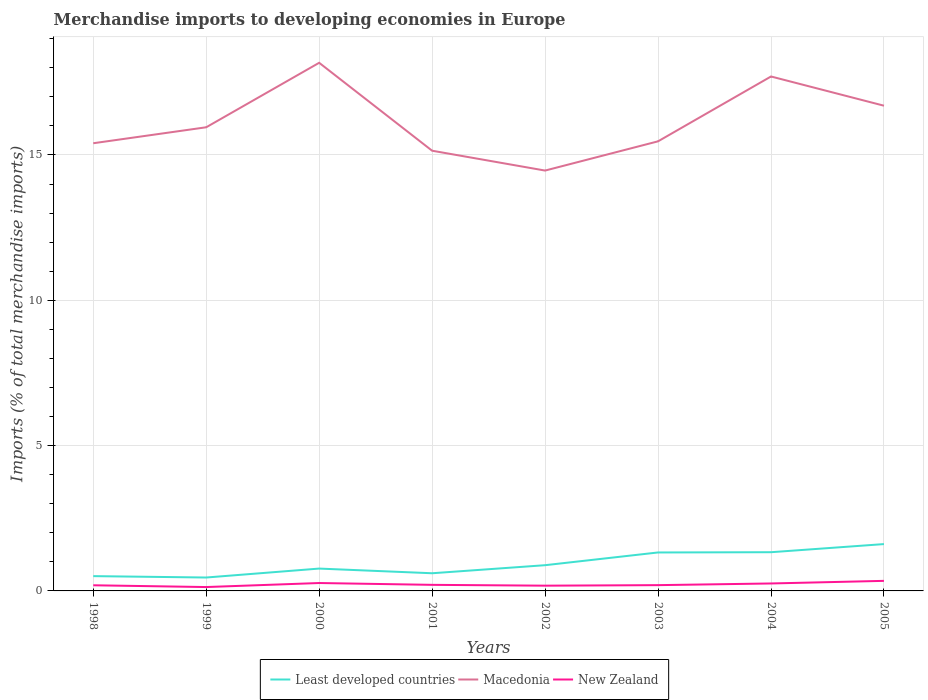How many different coloured lines are there?
Your response must be concise. 3. Is the number of lines equal to the number of legend labels?
Ensure brevity in your answer.  Yes. Across all years, what is the maximum percentage total merchandise imports in Macedonia?
Your response must be concise. 14.46. What is the total percentage total merchandise imports in Least developed countries in the graph?
Give a very brief answer. -0.72. What is the difference between the highest and the second highest percentage total merchandise imports in Least developed countries?
Offer a very short reply. 1.15. Is the percentage total merchandise imports in Least developed countries strictly greater than the percentage total merchandise imports in Macedonia over the years?
Your answer should be compact. Yes. How many lines are there?
Offer a terse response. 3. How many years are there in the graph?
Your answer should be compact. 8. Are the values on the major ticks of Y-axis written in scientific E-notation?
Your answer should be compact. No. Does the graph contain any zero values?
Your answer should be very brief. No. Does the graph contain grids?
Your answer should be compact. Yes. Where does the legend appear in the graph?
Your answer should be compact. Bottom center. How many legend labels are there?
Offer a very short reply. 3. How are the legend labels stacked?
Your response must be concise. Horizontal. What is the title of the graph?
Provide a short and direct response. Merchandise imports to developing economies in Europe. Does "San Marino" appear as one of the legend labels in the graph?
Your answer should be compact. No. What is the label or title of the Y-axis?
Your answer should be compact. Imports (% of total merchandise imports). What is the Imports (% of total merchandise imports) of Least developed countries in 1998?
Offer a very short reply. 0.51. What is the Imports (% of total merchandise imports) in Macedonia in 1998?
Ensure brevity in your answer.  15.4. What is the Imports (% of total merchandise imports) of New Zealand in 1998?
Offer a very short reply. 0.19. What is the Imports (% of total merchandise imports) of Least developed countries in 1999?
Offer a very short reply. 0.46. What is the Imports (% of total merchandise imports) of Macedonia in 1999?
Make the answer very short. 15.95. What is the Imports (% of total merchandise imports) in New Zealand in 1999?
Offer a very short reply. 0.13. What is the Imports (% of total merchandise imports) of Least developed countries in 2000?
Offer a terse response. 0.77. What is the Imports (% of total merchandise imports) in Macedonia in 2000?
Keep it short and to the point. 18.17. What is the Imports (% of total merchandise imports) of New Zealand in 2000?
Offer a terse response. 0.27. What is the Imports (% of total merchandise imports) of Least developed countries in 2001?
Give a very brief answer. 0.61. What is the Imports (% of total merchandise imports) of Macedonia in 2001?
Offer a very short reply. 15.15. What is the Imports (% of total merchandise imports) in New Zealand in 2001?
Make the answer very short. 0.21. What is the Imports (% of total merchandise imports) in Least developed countries in 2002?
Ensure brevity in your answer.  0.89. What is the Imports (% of total merchandise imports) of Macedonia in 2002?
Your answer should be compact. 14.46. What is the Imports (% of total merchandise imports) of New Zealand in 2002?
Provide a short and direct response. 0.18. What is the Imports (% of total merchandise imports) of Least developed countries in 2003?
Your response must be concise. 1.32. What is the Imports (% of total merchandise imports) in Macedonia in 2003?
Keep it short and to the point. 15.47. What is the Imports (% of total merchandise imports) in New Zealand in 2003?
Ensure brevity in your answer.  0.2. What is the Imports (% of total merchandise imports) of Least developed countries in 2004?
Make the answer very short. 1.33. What is the Imports (% of total merchandise imports) of Macedonia in 2004?
Offer a terse response. 17.7. What is the Imports (% of total merchandise imports) in New Zealand in 2004?
Give a very brief answer. 0.26. What is the Imports (% of total merchandise imports) of Least developed countries in 2005?
Ensure brevity in your answer.  1.61. What is the Imports (% of total merchandise imports) of Macedonia in 2005?
Make the answer very short. 16.7. What is the Imports (% of total merchandise imports) of New Zealand in 2005?
Offer a very short reply. 0.35. Across all years, what is the maximum Imports (% of total merchandise imports) in Least developed countries?
Make the answer very short. 1.61. Across all years, what is the maximum Imports (% of total merchandise imports) of Macedonia?
Your answer should be compact. 18.17. Across all years, what is the maximum Imports (% of total merchandise imports) in New Zealand?
Your answer should be very brief. 0.35. Across all years, what is the minimum Imports (% of total merchandise imports) of Least developed countries?
Make the answer very short. 0.46. Across all years, what is the minimum Imports (% of total merchandise imports) in Macedonia?
Make the answer very short. 14.46. Across all years, what is the minimum Imports (% of total merchandise imports) in New Zealand?
Your answer should be compact. 0.13. What is the total Imports (% of total merchandise imports) in Least developed countries in the graph?
Your response must be concise. 7.5. What is the total Imports (% of total merchandise imports) of Macedonia in the graph?
Keep it short and to the point. 129. What is the total Imports (% of total merchandise imports) of New Zealand in the graph?
Offer a very short reply. 1.79. What is the difference between the Imports (% of total merchandise imports) in Least developed countries in 1998 and that in 1999?
Offer a terse response. 0.05. What is the difference between the Imports (% of total merchandise imports) in Macedonia in 1998 and that in 1999?
Keep it short and to the point. -0.55. What is the difference between the Imports (% of total merchandise imports) of New Zealand in 1998 and that in 1999?
Your response must be concise. 0.06. What is the difference between the Imports (% of total merchandise imports) of Least developed countries in 1998 and that in 2000?
Your answer should be compact. -0.26. What is the difference between the Imports (% of total merchandise imports) of Macedonia in 1998 and that in 2000?
Your answer should be very brief. -2.77. What is the difference between the Imports (% of total merchandise imports) of New Zealand in 1998 and that in 2000?
Provide a short and direct response. -0.08. What is the difference between the Imports (% of total merchandise imports) of Least developed countries in 1998 and that in 2001?
Your answer should be very brief. -0.1. What is the difference between the Imports (% of total merchandise imports) in Macedonia in 1998 and that in 2001?
Your answer should be very brief. 0.26. What is the difference between the Imports (% of total merchandise imports) of New Zealand in 1998 and that in 2001?
Provide a succinct answer. -0.01. What is the difference between the Imports (% of total merchandise imports) in Least developed countries in 1998 and that in 2002?
Keep it short and to the point. -0.38. What is the difference between the Imports (% of total merchandise imports) of Macedonia in 1998 and that in 2002?
Offer a terse response. 0.94. What is the difference between the Imports (% of total merchandise imports) of New Zealand in 1998 and that in 2002?
Your answer should be very brief. 0.01. What is the difference between the Imports (% of total merchandise imports) in Least developed countries in 1998 and that in 2003?
Offer a terse response. -0.81. What is the difference between the Imports (% of total merchandise imports) of Macedonia in 1998 and that in 2003?
Your answer should be very brief. -0.07. What is the difference between the Imports (% of total merchandise imports) in New Zealand in 1998 and that in 2003?
Your answer should be compact. -0. What is the difference between the Imports (% of total merchandise imports) of Least developed countries in 1998 and that in 2004?
Your answer should be compact. -0.82. What is the difference between the Imports (% of total merchandise imports) of Macedonia in 1998 and that in 2004?
Give a very brief answer. -2.3. What is the difference between the Imports (% of total merchandise imports) in New Zealand in 1998 and that in 2004?
Offer a very short reply. -0.06. What is the difference between the Imports (% of total merchandise imports) in Least developed countries in 1998 and that in 2005?
Your answer should be compact. -1.1. What is the difference between the Imports (% of total merchandise imports) of Macedonia in 1998 and that in 2005?
Your answer should be very brief. -1.29. What is the difference between the Imports (% of total merchandise imports) in New Zealand in 1998 and that in 2005?
Provide a short and direct response. -0.15. What is the difference between the Imports (% of total merchandise imports) of Least developed countries in 1999 and that in 2000?
Provide a succinct answer. -0.31. What is the difference between the Imports (% of total merchandise imports) of Macedonia in 1999 and that in 2000?
Provide a short and direct response. -2.22. What is the difference between the Imports (% of total merchandise imports) in New Zealand in 1999 and that in 2000?
Keep it short and to the point. -0.14. What is the difference between the Imports (% of total merchandise imports) in Least developed countries in 1999 and that in 2001?
Make the answer very short. -0.15. What is the difference between the Imports (% of total merchandise imports) in Macedonia in 1999 and that in 2001?
Your answer should be compact. 0.81. What is the difference between the Imports (% of total merchandise imports) in New Zealand in 1999 and that in 2001?
Offer a terse response. -0.08. What is the difference between the Imports (% of total merchandise imports) in Least developed countries in 1999 and that in 2002?
Your response must be concise. -0.42. What is the difference between the Imports (% of total merchandise imports) in Macedonia in 1999 and that in 2002?
Provide a short and direct response. 1.49. What is the difference between the Imports (% of total merchandise imports) of New Zealand in 1999 and that in 2002?
Make the answer very short. -0.05. What is the difference between the Imports (% of total merchandise imports) in Least developed countries in 1999 and that in 2003?
Give a very brief answer. -0.86. What is the difference between the Imports (% of total merchandise imports) of Macedonia in 1999 and that in 2003?
Your answer should be compact. 0.48. What is the difference between the Imports (% of total merchandise imports) in New Zealand in 1999 and that in 2003?
Offer a very short reply. -0.07. What is the difference between the Imports (% of total merchandise imports) in Least developed countries in 1999 and that in 2004?
Provide a short and direct response. -0.87. What is the difference between the Imports (% of total merchandise imports) in Macedonia in 1999 and that in 2004?
Provide a succinct answer. -1.75. What is the difference between the Imports (% of total merchandise imports) in New Zealand in 1999 and that in 2004?
Ensure brevity in your answer.  -0.12. What is the difference between the Imports (% of total merchandise imports) in Least developed countries in 1999 and that in 2005?
Offer a terse response. -1.15. What is the difference between the Imports (% of total merchandise imports) of Macedonia in 1999 and that in 2005?
Keep it short and to the point. -0.74. What is the difference between the Imports (% of total merchandise imports) in New Zealand in 1999 and that in 2005?
Offer a terse response. -0.21. What is the difference between the Imports (% of total merchandise imports) of Least developed countries in 2000 and that in 2001?
Make the answer very short. 0.16. What is the difference between the Imports (% of total merchandise imports) in Macedonia in 2000 and that in 2001?
Keep it short and to the point. 3.03. What is the difference between the Imports (% of total merchandise imports) of New Zealand in 2000 and that in 2001?
Offer a very short reply. 0.06. What is the difference between the Imports (% of total merchandise imports) in Least developed countries in 2000 and that in 2002?
Give a very brief answer. -0.12. What is the difference between the Imports (% of total merchandise imports) of Macedonia in 2000 and that in 2002?
Keep it short and to the point. 3.71. What is the difference between the Imports (% of total merchandise imports) of New Zealand in 2000 and that in 2002?
Your response must be concise. 0.09. What is the difference between the Imports (% of total merchandise imports) of Least developed countries in 2000 and that in 2003?
Provide a short and direct response. -0.55. What is the difference between the Imports (% of total merchandise imports) in Macedonia in 2000 and that in 2003?
Ensure brevity in your answer.  2.7. What is the difference between the Imports (% of total merchandise imports) in New Zealand in 2000 and that in 2003?
Offer a very short reply. 0.07. What is the difference between the Imports (% of total merchandise imports) of Least developed countries in 2000 and that in 2004?
Provide a short and direct response. -0.56. What is the difference between the Imports (% of total merchandise imports) in Macedonia in 2000 and that in 2004?
Your answer should be very brief. 0.47. What is the difference between the Imports (% of total merchandise imports) of New Zealand in 2000 and that in 2004?
Ensure brevity in your answer.  0.02. What is the difference between the Imports (% of total merchandise imports) of Least developed countries in 2000 and that in 2005?
Provide a succinct answer. -0.84. What is the difference between the Imports (% of total merchandise imports) of Macedonia in 2000 and that in 2005?
Your answer should be very brief. 1.48. What is the difference between the Imports (% of total merchandise imports) of New Zealand in 2000 and that in 2005?
Offer a very short reply. -0.07. What is the difference between the Imports (% of total merchandise imports) in Least developed countries in 2001 and that in 2002?
Make the answer very short. -0.28. What is the difference between the Imports (% of total merchandise imports) of Macedonia in 2001 and that in 2002?
Make the answer very short. 0.68. What is the difference between the Imports (% of total merchandise imports) in New Zealand in 2001 and that in 2002?
Give a very brief answer. 0.03. What is the difference between the Imports (% of total merchandise imports) in Least developed countries in 2001 and that in 2003?
Your answer should be very brief. -0.72. What is the difference between the Imports (% of total merchandise imports) of Macedonia in 2001 and that in 2003?
Offer a very short reply. -0.32. What is the difference between the Imports (% of total merchandise imports) of New Zealand in 2001 and that in 2003?
Ensure brevity in your answer.  0.01. What is the difference between the Imports (% of total merchandise imports) in Least developed countries in 2001 and that in 2004?
Keep it short and to the point. -0.72. What is the difference between the Imports (% of total merchandise imports) in Macedonia in 2001 and that in 2004?
Offer a very short reply. -2.55. What is the difference between the Imports (% of total merchandise imports) in New Zealand in 2001 and that in 2004?
Offer a very short reply. -0.05. What is the difference between the Imports (% of total merchandise imports) of Least developed countries in 2001 and that in 2005?
Make the answer very short. -1. What is the difference between the Imports (% of total merchandise imports) in Macedonia in 2001 and that in 2005?
Ensure brevity in your answer.  -1.55. What is the difference between the Imports (% of total merchandise imports) in New Zealand in 2001 and that in 2005?
Provide a succinct answer. -0.14. What is the difference between the Imports (% of total merchandise imports) in Least developed countries in 2002 and that in 2003?
Give a very brief answer. -0.44. What is the difference between the Imports (% of total merchandise imports) in Macedonia in 2002 and that in 2003?
Offer a very short reply. -1.01. What is the difference between the Imports (% of total merchandise imports) of New Zealand in 2002 and that in 2003?
Give a very brief answer. -0.02. What is the difference between the Imports (% of total merchandise imports) in Least developed countries in 2002 and that in 2004?
Provide a succinct answer. -0.45. What is the difference between the Imports (% of total merchandise imports) of Macedonia in 2002 and that in 2004?
Offer a terse response. -3.24. What is the difference between the Imports (% of total merchandise imports) of New Zealand in 2002 and that in 2004?
Your response must be concise. -0.08. What is the difference between the Imports (% of total merchandise imports) of Least developed countries in 2002 and that in 2005?
Give a very brief answer. -0.73. What is the difference between the Imports (% of total merchandise imports) of Macedonia in 2002 and that in 2005?
Keep it short and to the point. -2.23. What is the difference between the Imports (% of total merchandise imports) in New Zealand in 2002 and that in 2005?
Provide a succinct answer. -0.17. What is the difference between the Imports (% of total merchandise imports) in Least developed countries in 2003 and that in 2004?
Ensure brevity in your answer.  -0.01. What is the difference between the Imports (% of total merchandise imports) of Macedonia in 2003 and that in 2004?
Provide a succinct answer. -2.23. What is the difference between the Imports (% of total merchandise imports) of New Zealand in 2003 and that in 2004?
Make the answer very short. -0.06. What is the difference between the Imports (% of total merchandise imports) of Least developed countries in 2003 and that in 2005?
Make the answer very short. -0.29. What is the difference between the Imports (% of total merchandise imports) in Macedonia in 2003 and that in 2005?
Ensure brevity in your answer.  -1.23. What is the difference between the Imports (% of total merchandise imports) of New Zealand in 2003 and that in 2005?
Give a very brief answer. -0.15. What is the difference between the Imports (% of total merchandise imports) of Least developed countries in 2004 and that in 2005?
Give a very brief answer. -0.28. What is the difference between the Imports (% of total merchandise imports) of Macedonia in 2004 and that in 2005?
Give a very brief answer. 1. What is the difference between the Imports (% of total merchandise imports) of New Zealand in 2004 and that in 2005?
Keep it short and to the point. -0.09. What is the difference between the Imports (% of total merchandise imports) of Least developed countries in 1998 and the Imports (% of total merchandise imports) of Macedonia in 1999?
Keep it short and to the point. -15.44. What is the difference between the Imports (% of total merchandise imports) in Least developed countries in 1998 and the Imports (% of total merchandise imports) in New Zealand in 1999?
Provide a succinct answer. 0.38. What is the difference between the Imports (% of total merchandise imports) of Macedonia in 1998 and the Imports (% of total merchandise imports) of New Zealand in 1999?
Give a very brief answer. 15.27. What is the difference between the Imports (% of total merchandise imports) of Least developed countries in 1998 and the Imports (% of total merchandise imports) of Macedonia in 2000?
Keep it short and to the point. -17.66. What is the difference between the Imports (% of total merchandise imports) of Least developed countries in 1998 and the Imports (% of total merchandise imports) of New Zealand in 2000?
Ensure brevity in your answer.  0.24. What is the difference between the Imports (% of total merchandise imports) of Macedonia in 1998 and the Imports (% of total merchandise imports) of New Zealand in 2000?
Ensure brevity in your answer.  15.13. What is the difference between the Imports (% of total merchandise imports) of Least developed countries in 1998 and the Imports (% of total merchandise imports) of Macedonia in 2001?
Provide a short and direct response. -14.64. What is the difference between the Imports (% of total merchandise imports) in Least developed countries in 1998 and the Imports (% of total merchandise imports) in New Zealand in 2001?
Your answer should be very brief. 0.3. What is the difference between the Imports (% of total merchandise imports) in Macedonia in 1998 and the Imports (% of total merchandise imports) in New Zealand in 2001?
Your answer should be very brief. 15.19. What is the difference between the Imports (% of total merchandise imports) in Least developed countries in 1998 and the Imports (% of total merchandise imports) in Macedonia in 2002?
Give a very brief answer. -13.95. What is the difference between the Imports (% of total merchandise imports) of Least developed countries in 1998 and the Imports (% of total merchandise imports) of New Zealand in 2002?
Offer a terse response. 0.33. What is the difference between the Imports (% of total merchandise imports) of Macedonia in 1998 and the Imports (% of total merchandise imports) of New Zealand in 2002?
Make the answer very short. 15.22. What is the difference between the Imports (% of total merchandise imports) of Least developed countries in 1998 and the Imports (% of total merchandise imports) of Macedonia in 2003?
Give a very brief answer. -14.96. What is the difference between the Imports (% of total merchandise imports) in Least developed countries in 1998 and the Imports (% of total merchandise imports) in New Zealand in 2003?
Offer a very short reply. 0.31. What is the difference between the Imports (% of total merchandise imports) of Macedonia in 1998 and the Imports (% of total merchandise imports) of New Zealand in 2003?
Offer a terse response. 15.21. What is the difference between the Imports (% of total merchandise imports) of Least developed countries in 1998 and the Imports (% of total merchandise imports) of Macedonia in 2004?
Make the answer very short. -17.19. What is the difference between the Imports (% of total merchandise imports) in Least developed countries in 1998 and the Imports (% of total merchandise imports) in New Zealand in 2004?
Keep it short and to the point. 0.25. What is the difference between the Imports (% of total merchandise imports) of Macedonia in 1998 and the Imports (% of total merchandise imports) of New Zealand in 2004?
Provide a succinct answer. 15.15. What is the difference between the Imports (% of total merchandise imports) of Least developed countries in 1998 and the Imports (% of total merchandise imports) of Macedonia in 2005?
Keep it short and to the point. -16.19. What is the difference between the Imports (% of total merchandise imports) in Least developed countries in 1998 and the Imports (% of total merchandise imports) in New Zealand in 2005?
Provide a short and direct response. 0.16. What is the difference between the Imports (% of total merchandise imports) of Macedonia in 1998 and the Imports (% of total merchandise imports) of New Zealand in 2005?
Ensure brevity in your answer.  15.06. What is the difference between the Imports (% of total merchandise imports) in Least developed countries in 1999 and the Imports (% of total merchandise imports) in Macedonia in 2000?
Your response must be concise. -17.71. What is the difference between the Imports (% of total merchandise imports) of Least developed countries in 1999 and the Imports (% of total merchandise imports) of New Zealand in 2000?
Ensure brevity in your answer.  0.19. What is the difference between the Imports (% of total merchandise imports) in Macedonia in 1999 and the Imports (% of total merchandise imports) in New Zealand in 2000?
Provide a short and direct response. 15.68. What is the difference between the Imports (% of total merchandise imports) of Least developed countries in 1999 and the Imports (% of total merchandise imports) of Macedonia in 2001?
Offer a very short reply. -14.69. What is the difference between the Imports (% of total merchandise imports) of Least developed countries in 1999 and the Imports (% of total merchandise imports) of New Zealand in 2001?
Provide a short and direct response. 0.25. What is the difference between the Imports (% of total merchandise imports) in Macedonia in 1999 and the Imports (% of total merchandise imports) in New Zealand in 2001?
Your response must be concise. 15.74. What is the difference between the Imports (% of total merchandise imports) of Least developed countries in 1999 and the Imports (% of total merchandise imports) of Macedonia in 2002?
Give a very brief answer. -14. What is the difference between the Imports (% of total merchandise imports) in Least developed countries in 1999 and the Imports (% of total merchandise imports) in New Zealand in 2002?
Ensure brevity in your answer.  0.28. What is the difference between the Imports (% of total merchandise imports) of Macedonia in 1999 and the Imports (% of total merchandise imports) of New Zealand in 2002?
Keep it short and to the point. 15.77. What is the difference between the Imports (% of total merchandise imports) of Least developed countries in 1999 and the Imports (% of total merchandise imports) of Macedonia in 2003?
Give a very brief answer. -15.01. What is the difference between the Imports (% of total merchandise imports) of Least developed countries in 1999 and the Imports (% of total merchandise imports) of New Zealand in 2003?
Make the answer very short. 0.26. What is the difference between the Imports (% of total merchandise imports) of Macedonia in 1999 and the Imports (% of total merchandise imports) of New Zealand in 2003?
Your response must be concise. 15.75. What is the difference between the Imports (% of total merchandise imports) in Least developed countries in 1999 and the Imports (% of total merchandise imports) in Macedonia in 2004?
Your answer should be very brief. -17.24. What is the difference between the Imports (% of total merchandise imports) in Least developed countries in 1999 and the Imports (% of total merchandise imports) in New Zealand in 2004?
Make the answer very short. 0.2. What is the difference between the Imports (% of total merchandise imports) in Macedonia in 1999 and the Imports (% of total merchandise imports) in New Zealand in 2004?
Your answer should be compact. 15.7. What is the difference between the Imports (% of total merchandise imports) in Least developed countries in 1999 and the Imports (% of total merchandise imports) in Macedonia in 2005?
Offer a very short reply. -16.23. What is the difference between the Imports (% of total merchandise imports) of Least developed countries in 1999 and the Imports (% of total merchandise imports) of New Zealand in 2005?
Provide a short and direct response. 0.12. What is the difference between the Imports (% of total merchandise imports) of Macedonia in 1999 and the Imports (% of total merchandise imports) of New Zealand in 2005?
Make the answer very short. 15.61. What is the difference between the Imports (% of total merchandise imports) in Least developed countries in 2000 and the Imports (% of total merchandise imports) in Macedonia in 2001?
Your answer should be compact. -14.38. What is the difference between the Imports (% of total merchandise imports) of Least developed countries in 2000 and the Imports (% of total merchandise imports) of New Zealand in 2001?
Your answer should be compact. 0.56. What is the difference between the Imports (% of total merchandise imports) of Macedonia in 2000 and the Imports (% of total merchandise imports) of New Zealand in 2001?
Offer a very short reply. 17.96. What is the difference between the Imports (% of total merchandise imports) in Least developed countries in 2000 and the Imports (% of total merchandise imports) in Macedonia in 2002?
Your response must be concise. -13.69. What is the difference between the Imports (% of total merchandise imports) of Least developed countries in 2000 and the Imports (% of total merchandise imports) of New Zealand in 2002?
Keep it short and to the point. 0.59. What is the difference between the Imports (% of total merchandise imports) of Macedonia in 2000 and the Imports (% of total merchandise imports) of New Zealand in 2002?
Give a very brief answer. 17.99. What is the difference between the Imports (% of total merchandise imports) in Least developed countries in 2000 and the Imports (% of total merchandise imports) in Macedonia in 2003?
Make the answer very short. -14.7. What is the difference between the Imports (% of total merchandise imports) of Least developed countries in 2000 and the Imports (% of total merchandise imports) of New Zealand in 2003?
Your answer should be compact. 0.57. What is the difference between the Imports (% of total merchandise imports) of Macedonia in 2000 and the Imports (% of total merchandise imports) of New Zealand in 2003?
Your answer should be compact. 17.97. What is the difference between the Imports (% of total merchandise imports) of Least developed countries in 2000 and the Imports (% of total merchandise imports) of Macedonia in 2004?
Your answer should be compact. -16.93. What is the difference between the Imports (% of total merchandise imports) of Least developed countries in 2000 and the Imports (% of total merchandise imports) of New Zealand in 2004?
Your answer should be compact. 0.51. What is the difference between the Imports (% of total merchandise imports) in Macedonia in 2000 and the Imports (% of total merchandise imports) in New Zealand in 2004?
Offer a terse response. 17.92. What is the difference between the Imports (% of total merchandise imports) of Least developed countries in 2000 and the Imports (% of total merchandise imports) of Macedonia in 2005?
Offer a very short reply. -15.93. What is the difference between the Imports (% of total merchandise imports) of Least developed countries in 2000 and the Imports (% of total merchandise imports) of New Zealand in 2005?
Offer a very short reply. 0.42. What is the difference between the Imports (% of total merchandise imports) of Macedonia in 2000 and the Imports (% of total merchandise imports) of New Zealand in 2005?
Give a very brief answer. 17.83. What is the difference between the Imports (% of total merchandise imports) in Least developed countries in 2001 and the Imports (% of total merchandise imports) in Macedonia in 2002?
Keep it short and to the point. -13.86. What is the difference between the Imports (% of total merchandise imports) of Least developed countries in 2001 and the Imports (% of total merchandise imports) of New Zealand in 2002?
Your response must be concise. 0.43. What is the difference between the Imports (% of total merchandise imports) of Macedonia in 2001 and the Imports (% of total merchandise imports) of New Zealand in 2002?
Your response must be concise. 14.97. What is the difference between the Imports (% of total merchandise imports) in Least developed countries in 2001 and the Imports (% of total merchandise imports) in Macedonia in 2003?
Provide a succinct answer. -14.86. What is the difference between the Imports (% of total merchandise imports) in Least developed countries in 2001 and the Imports (% of total merchandise imports) in New Zealand in 2003?
Keep it short and to the point. 0.41. What is the difference between the Imports (% of total merchandise imports) of Macedonia in 2001 and the Imports (% of total merchandise imports) of New Zealand in 2003?
Your answer should be compact. 14.95. What is the difference between the Imports (% of total merchandise imports) of Least developed countries in 2001 and the Imports (% of total merchandise imports) of Macedonia in 2004?
Offer a very short reply. -17.09. What is the difference between the Imports (% of total merchandise imports) in Least developed countries in 2001 and the Imports (% of total merchandise imports) in New Zealand in 2004?
Offer a very short reply. 0.35. What is the difference between the Imports (% of total merchandise imports) of Macedonia in 2001 and the Imports (% of total merchandise imports) of New Zealand in 2004?
Provide a short and direct response. 14.89. What is the difference between the Imports (% of total merchandise imports) of Least developed countries in 2001 and the Imports (% of total merchandise imports) of Macedonia in 2005?
Your answer should be compact. -16.09. What is the difference between the Imports (% of total merchandise imports) of Least developed countries in 2001 and the Imports (% of total merchandise imports) of New Zealand in 2005?
Offer a very short reply. 0.26. What is the difference between the Imports (% of total merchandise imports) in Macedonia in 2001 and the Imports (% of total merchandise imports) in New Zealand in 2005?
Provide a succinct answer. 14.8. What is the difference between the Imports (% of total merchandise imports) in Least developed countries in 2002 and the Imports (% of total merchandise imports) in Macedonia in 2003?
Your answer should be compact. -14.58. What is the difference between the Imports (% of total merchandise imports) of Least developed countries in 2002 and the Imports (% of total merchandise imports) of New Zealand in 2003?
Provide a succinct answer. 0.69. What is the difference between the Imports (% of total merchandise imports) of Macedonia in 2002 and the Imports (% of total merchandise imports) of New Zealand in 2003?
Keep it short and to the point. 14.26. What is the difference between the Imports (% of total merchandise imports) of Least developed countries in 2002 and the Imports (% of total merchandise imports) of Macedonia in 2004?
Your answer should be very brief. -16.82. What is the difference between the Imports (% of total merchandise imports) in Least developed countries in 2002 and the Imports (% of total merchandise imports) in New Zealand in 2004?
Provide a succinct answer. 0.63. What is the difference between the Imports (% of total merchandise imports) of Macedonia in 2002 and the Imports (% of total merchandise imports) of New Zealand in 2004?
Your answer should be compact. 14.21. What is the difference between the Imports (% of total merchandise imports) in Least developed countries in 2002 and the Imports (% of total merchandise imports) in Macedonia in 2005?
Offer a very short reply. -15.81. What is the difference between the Imports (% of total merchandise imports) in Least developed countries in 2002 and the Imports (% of total merchandise imports) in New Zealand in 2005?
Keep it short and to the point. 0.54. What is the difference between the Imports (% of total merchandise imports) of Macedonia in 2002 and the Imports (% of total merchandise imports) of New Zealand in 2005?
Your answer should be compact. 14.12. What is the difference between the Imports (% of total merchandise imports) of Least developed countries in 2003 and the Imports (% of total merchandise imports) of Macedonia in 2004?
Offer a very short reply. -16.38. What is the difference between the Imports (% of total merchandise imports) in Least developed countries in 2003 and the Imports (% of total merchandise imports) in New Zealand in 2004?
Offer a terse response. 1.07. What is the difference between the Imports (% of total merchandise imports) in Macedonia in 2003 and the Imports (% of total merchandise imports) in New Zealand in 2004?
Make the answer very short. 15.21. What is the difference between the Imports (% of total merchandise imports) of Least developed countries in 2003 and the Imports (% of total merchandise imports) of Macedonia in 2005?
Your answer should be compact. -15.37. What is the difference between the Imports (% of total merchandise imports) in Least developed countries in 2003 and the Imports (% of total merchandise imports) in New Zealand in 2005?
Provide a short and direct response. 0.98. What is the difference between the Imports (% of total merchandise imports) in Macedonia in 2003 and the Imports (% of total merchandise imports) in New Zealand in 2005?
Give a very brief answer. 15.12. What is the difference between the Imports (% of total merchandise imports) in Least developed countries in 2004 and the Imports (% of total merchandise imports) in Macedonia in 2005?
Offer a terse response. -15.36. What is the difference between the Imports (% of total merchandise imports) of Macedonia in 2004 and the Imports (% of total merchandise imports) of New Zealand in 2005?
Keep it short and to the point. 17.35. What is the average Imports (% of total merchandise imports) of Least developed countries per year?
Give a very brief answer. 0.94. What is the average Imports (% of total merchandise imports) of Macedonia per year?
Offer a terse response. 16.13. What is the average Imports (% of total merchandise imports) in New Zealand per year?
Ensure brevity in your answer.  0.22. In the year 1998, what is the difference between the Imports (% of total merchandise imports) in Least developed countries and Imports (% of total merchandise imports) in Macedonia?
Give a very brief answer. -14.89. In the year 1998, what is the difference between the Imports (% of total merchandise imports) of Least developed countries and Imports (% of total merchandise imports) of New Zealand?
Provide a succinct answer. 0.32. In the year 1998, what is the difference between the Imports (% of total merchandise imports) of Macedonia and Imports (% of total merchandise imports) of New Zealand?
Make the answer very short. 15.21. In the year 1999, what is the difference between the Imports (% of total merchandise imports) of Least developed countries and Imports (% of total merchandise imports) of Macedonia?
Ensure brevity in your answer.  -15.49. In the year 1999, what is the difference between the Imports (% of total merchandise imports) in Least developed countries and Imports (% of total merchandise imports) in New Zealand?
Offer a very short reply. 0.33. In the year 1999, what is the difference between the Imports (% of total merchandise imports) of Macedonia and Imports (% of total merchandise imports) of New Zealand?
Give a very brief answer. 15.82. In the year 2000, what is the difference between the Imports (% of total merchandise imports) of Least developed countries and Imports (% of total merchandise imports) of Macedonia?
Your answer should be very brief. -17.4. In the year 2000, what is the difference between the Imports (% of total merchandise imports) of Least developed countries and Imports (% of total merchandise imports) of New Zealand?
Keep it short and to the point. 0.5. In the year 2000, what is the difference between the Imports (% of total merchandise imports) of Macedonia and Imports (% of total merchandise imports) of New Zealand?
Offer a terse response. 17.9. In the year 2001, what is the difference between the Imports (% of total merchandise imports) of Least developed countries and Imports (% of total merchandise imports) of Macedonia?
Provide a succinct answer. -14.54. In the year 2001, what is the difference between the Imports (% of total merchandise imports) in Least developed countries and Imports (% of total merchandise imports) in New Zealand?
Provide a short and direct response. 0.4. In the year 2001, what is the difference between the Imports (% of total merchandise imports) in Macedonia and Imports (% of total merchandise imports) in New Zealand?
Make the answer very short. 14.94. In the year 2002, what is the difference between the Imports (% of total merchandise imports) of Least developed countries and Imports (% of total merchandise imports) of Macedonia?
Give a very brief answer. -13.58. In the year 2002, what is the difference between the Imports (% of total merchandise imports) of Least developed countries and Imports (% of total merchandise imports) of New Zealand?
Your answer should be compact. 0.7. In the year 2002, what is the difference between the Imports (% of total merchandise imports) of Macedonia and Imports (% of total merchandise imports) of New Zealand?
Ensure brevity in your answer.  14.28. In the year 2003, what is the difference between the Imports (% of total merchandise imports) of Least developed countries and Imports (% of total merchandise imports) of Macedonia?
Give a very brief answer. -14.15. In the year 2003, what is the difference between the Imports (% of total merchandise imports) in Least developed countries and Imports (% of total merchandise imports) in New Zealand?
Your answer should be compact. 1.12. In the year 2003, what is the difference between the Imports (% of total merchandise imports) in Macedonia and Imports (% of total merchandise imports) in New Zealand?
Provide a short and direct response. 15.27. In the year 2004, what is the difference between the Imports (% of total merchandise imports) of Least developed countries and Imports (% of total merchandise imports) of Macedonia?
Your response must be concise. -16.37. In the year 2004, what is the difference between the Imports (% of total merchandise imports) in Least developed countries and Imports (% of total merchandise imports) in New Zealand?
Give a very brief answer. 1.08. In the year 2004, what is the difference between the Imports (% of total merchandise imports) in Macedonia and Imports (% of total merchandise imports) in New Zealand?
Your answer should be very brief. 17.44. In the year 2005, what is the difference between the Imports (% of total merchandise imports) in Least developed countries and Imports (% of total merchandise imports) in Macedonia?
Keep it short and to the point. -15.08. In the year 2005, what is the difference between the Imports (% of total merchandise imports) of Least developed countries and Imports (% of total merchandise imports) of New Zealand?
Make the answer very short. 1.27. In the year 2005, what is the difference between the Imports (% of total merchandise imports) in Macedonia and Imports (% of total merchandise imports) in New Zealand?
Your answer should be very brief. 16.35. What is the ratio of the Imports (% of total merchandise imports) in Least developed countries in 1998 to that in 1999?
Give a very brief answer. 1.1. What is the ratio of the Imports (% of total merchandise imports) of Macedonia in 1998 to that in 1999?
Your answer should be very brief. 0.97. What is the ratio of the Imports (% of total merchandise imports) in New Zealand in 1998 to that in 1999?
Provide a succinct answer. 1.46. What is the ratio of the Imports (% of total merchandise imports) of Least developed countries in 1998 to that in 2000?
Your answer should be compact. 0.66. What is the ratio of the Imports (% of total merchandise imports) in Macedonia in 1998 to that in 2000?
Ensure brevity in your answer.  0.85. What is the ratio of the Imports (% of total merchandise imports) of New Zealand in 1998 to that in 2000?
Ensure brevity in your answer.  0.71. What is the ratio of the Imports (% of total merchandise imports) of Least developed countries in 1998 to that in 2001?
Offer a terse response. 0.84. What is the ratio of the Imports (% of total merchandise imports) of New Zealand in 1998 to that in 2001?
Make the answer very short. 0.93. What is the ratio of the Imports (% of total merchandise imports) in Least developed countries in 1998 to that in 2002?
Provide a short and direct response. 0.58. What is the ratio of the Imports (% of total merchandise imports) in Macedonia in 1998 to that in 2002?
Keep it short and to the point. 1.06. What is the ratio of the Imports (% of total merchandise imports) in New Zealand in 1998 to that in 2002?
Keep it short and to the point. 1.07. What is the ratio of the Imports (% of total merchandise imports) of Least developed countries in 1998 to that in 2003?
Give a very brief answer. 0.38. What is the ratio of the Imports (% of total merchandise imports) in New Zealand in 1998 to that in 2003?
Make the answer very short. 0.98. What is the ratio of the Imports (% of total merchandise imports) of Least developed countries in 1998 to that in 2004?
Offer a terse response. 0.38. What is the ratio of the Imports (% of total merchandise imports) in Macedonia in 1998 to that in 2004?
Provide a short and direct response. 0.87. What is the ratio of the Imports (% of total merchandise imports) of New Zealand in 1998 to that in 2004?
Keep it short and to the point. 0.76. What is the ratio of the Imports (% of total merchandise imports) in Least developed countries in 1998 to that in 2005?
Offer a very short reply. 0.32. What is the ratio of the Imports (% of total merchandise imports) in Macedonia in 1998 to that in 2005?
Offer a terse response. 0.92. What is the ratio of the Imports (% of total merchandise imports) of New Zealand in 1998 to that in 2005?
Your answer should be very brief. 0.56. What is the ratio of the Imports (% of total merchandise imports) of Least developed countries in 1999 to that in 2000?
Provide a succinct answer. 0.6. What is the ratio of the Imports (% of total merchandise imports) in Macedonia in 1999 to that in 2000?
Provide a succinct answer. 0.88. What is the ratio of the Imports (% of total merchandise imports) of New Zealand in 1999 to that in 2000?
Your response must be concise. 0.49. What is the ratio of the Imports (% of total merchandise imports) of Least developed countries in 1999 to that in 2001?
Keep it short and to the point. 0.76. What is the ratio of the Imports (% of total merchandise imports) in Macedonia in 1999 to that in 2001?
Your answer should be very brief. 1.05. What is the ratio of the Imports (% of total merchandise imports) in New Zealand in 1999 to that in 2001?
Give a very brief answer. 0.64. What is the ratio of the Imports (% of total merchandise imports) of Least developed countries in 1999 to that in 2002?
Your answer should be very brief. 0.52. What is the ratio of the Imports (% of total merchandise imports) in Macedonia in 1999 to that in 2002?
Make the answer very short. 1.1. What is the ratio of the Imports (% of total merchandise imports) of New Zealand in 1999 to that in 2002?
Your answer should be compact. 0.74. What is the ratio of the Imports (% of total merchandise imports) in Least developed countries in 1999 to that in 2003?
Your response must be concise. 0.35. What is the ratio of the Imports (% of total merchandise imports) of Macedonia in 1999 to that in 2003?
Provide a succinct answer. 1.03. What is the ratio of the Imports (% of total merchandise imports) in New Zealand in 1999 to that in 2003?
Offer a terse response. 0.67. What is the ratio of the Imports (% of total merchandise imports) of Least developed countries in 1999 to that in 2004?
Make the answer very short. 0.35. What is the ratio of the Imports (% of total merchandise imports) of Macedonia in 1999 to that in 2004?
Make the answer very short. 0.9. What is the ratio of the Imports (% of total merchandise imports) in New Zealand in 1999 to that in 2004?
Provide a short and direct response. 0.52. What is the ratio of the Imports (% of total merchandise imports) in Least developed countries in 1999 to that in 2005?
Ensure brevity in your answer.  0.29. What is the ratio of the Imports (% of total merchandise imports) in Macedonia in 1999 to that in 2005?
Your response must be concise. 0.96. What is the ratio of the Imports (% of total merchandise imports) in New Zealand in 1999 to that in 2005?
Your answer should be very brief. 0.39. What is the ratio of the Imports (% of total merchandise imports) in Least developed countries in 2000 to that in 2001?
Offer a very short reply. 1.26. What is the ratio of the Imports (% of total merchandise imports) in Macedonia in 2000 to that in 2001?
Your response must be concise. 1.2. What is the ratio of the Imports (% of total merchandise imports) in New Zealand in 2000 to that in 2001?
Make the answer very short. 1.3. What is the ratio of the Imports (% of total merchandise imports) of Least developed countries in 2000 to that in 2002?
Give a very brief answer. 0.87. What is the ratio of the Imports (% of total merchandise imports) of Macedonia in 2000 to that in 2002?
Your answer should be compact. 1.26. What is the ratio of the Imports (% of total merchandise imports) of New Zealand in 2000 to that in 2002?
Provide a short and direct response. 1.5. What is the ratio of the Imports (% of total merchandise imports) of Least developed countries in 2000 to that in 2003?
Your response must be concise. 0.58. What is the ratio of the Imports (% of total merchandise imports) of Macedonia in 2000 to that in 2003?
Provide a short and direct response. 1.17. What is the ratio of the Imports (% of total merchandise imports) in New Zealand in 2000 to that in 2003?
Give a very brief answer. 1.37. What is the ratio of the Imports (% of total merchandise imports) of Least developed countries in 2000 to that in 2004?
Ensure brevity in your answer.  0.58. What is the ratio of the Imports (% of total merchandise imports) in Macedonia in 2000 to that in 2004?
Offer a terse response. 1.03. What is the ratio of the Imports (% of total merchandise imports) in New Zealand in 2000 to that in 2004?
Offer a terse response. 1.06. What is the ratio of the Imports (% of total merchandise imports) in Least developed countries in 2000 to that in 2005?
Keep it short and to the point. 0.48. What is the ratio of the Imports (% of total merchandise imports) of Macedonia in 2000 to that in 2005?
Your answer should be very brief. 1.09. What is the ratio of the Imports (% of total merchandise imports) of New Zealand in 2000 to that in 2005?
Your response must be concise. 0.79. What is the ratio of the Imports (% of total merchandise imports) of Least developed countries in 2001 to that in 2002?
Give a very brief answer. 0.69. What is the ratio of the Imports (% of total merchandise imports) of Macedonia in 2001 to that in 2002?
Keep it short and to the point. 1.05. What is the ratio of the Imports (% of total merchandise imports) in New Zealand in 2001 to that in 2002?
Ensure brevity in your answer.  1.16. What is the ratio of the Imports (% of total merchandise imports) in Least developed countries in 2001 to that in 2003?
Provide a succinct answer. 0.46. What is the ratio of the Imports (% of total merchandise imports) of Macedonia in 2001 to that in 2003?
Provide a succinct answer. 0.98. What is the ratio of the Imports (% of total merchandise imports) of New Zealand in 2001 to that in 2003?
Make the answer very short. 1.05. What is the ratio of the Imports (% of total merchandise imports) in Least developed countries in 2001 to that in 2004?
Give a very brief answer. 0.46. What is the ratio of the Imports (% of total merchandise imports) in Macedonia in 2001 to that in 2004?
Provide a short and direct response. 0.86. What is the ratio of the Imports (% of total merchandise imports) of New Zealand in 2001 to that in 2004?
Ensure brevity in your answer.  0.81. What is the ratio of the Imports (% of total merchandise imports) of Least developed countries in 2001 to that in 2005?
Offer a terse response. 0.38. What is the ratio of the Imports (% of total merchandise imports) of Macedonia in 2001 to that in 2005?
Your answer should be compact. 0.91. What is the ratio of the Imports (% of total merchandise imports) of New Zealand in 2001 to that in 2005?
Give a very brief answer. 0.6. What is the ratio of the Imports (% of total merchandise imports) of Least developed countries in 2002 to that in 2003?
Your response must be concise. 0.67. What is the ratio of the Imports (% of total merchandise imports) in Macedonia in 2002 to that in 2003?
Your response must be concise. 0.94. What is the ratio of the Imports (% of total merchandise imports) in New Zealand in 2002 to that in 2003?
Ensure brevity in your answer.  0.91. What is the ratio of the Imports (% of total merchandise imports) in Least developed countries in 2002 to that in 2004?
Provide a succinct answer. 0.66. What is the ratio of the Imports (% of total merchandise imports) in Macedonia in 2002 to that in 2004?
Make the answer very short. 0.82. What is the ratio of the Imports (% of total merchandise imports) of New Zealand in 2002 to that in 2004?
Ensure brevity in your answer.  0.7. What is the ratio of the Imports (% of total merchandise imports) of Least developed countries in 2002 to that in 2005?
Ensure brevity in your answer.  0.55. What is the ratio of the Imports (% of total merchandise imports) in Macedonia in 2002 to that in 2005?
Your answer should be very brief. 0.87. What is the ratio of the Imports (% of total merchandise imports) of New Zealand in 2002 to that in 2005?
Keep it short and to the point. 0.52. What is the ratio of the Imports (% of total merchandise imports) of Least developed countries in 2003 to that in 2004?
Offer a very short reply. 0.99. What is the ratio of the Imports (% of total merchandise imports) in Macedonia in 2003 to that in 2004?
Provide a succinct answer. 0.87. What is the ratio of the Imports (% of total merchandise imports) of New Zealand in 2003 to that in 2004?
Your answer should be compact. 0.77. What is the ratio of the Imports (% of total merchandise imports) of Least developed countries in 2003 to that in 2005?
Your answer should be very brief. 0.82. What is the ratio of the Imports (% of total merchandise imports) of Macedonia in 2003 to that in 2005?
Your answer should be very brief. 0.93. What is the ratio of the Imports (% of total merchandise imports) of New Zealand in 2003 to that in 2005?
Offer a terse response. 0.57. What is the ratio of the Imports (% of total merchandise imports) of Least developed countries in 2004 to that in 2005?
Provide a short and direct response. 0.83. What is the ratio of the Imports (% of total merchandise imports) in Macedonia in 2004 to that in 2005?
Offer a very short reply. 1.06. What is the ratio of the Imports (% of total merchandise imports) of New Zealand in 2004 to that in 2005?
Make the answer very short. 0.74. What is the difference between the highest and the second highest Imports (% of total merchandise imports) in Least developed countries?
Your answer should be compact. 0.28. What is the difference between the highest and the second highest Imports (% of total merchandise imports) in Macedonia?
Keep it short and to the point. 0.47. What is the difference between the highest and the second highest Imports (% of total merchandise imports) in New Zealand?
Your response must be concise. 0.07. What is the difference between the highest and the lowest Imports (% of total merchandise imports) in Least developed countries?
Provide a short and direct response. 1.15. What is the difference between the highest and the lowest Imports (% of total merchandise imports) of Macedonia?
Your answer should be very brief. 3.71. What is the difference between the highest and the lowest Imports (% of total merchandise imports) of New Zealand?
Provide a short and direct response. 0.21. 